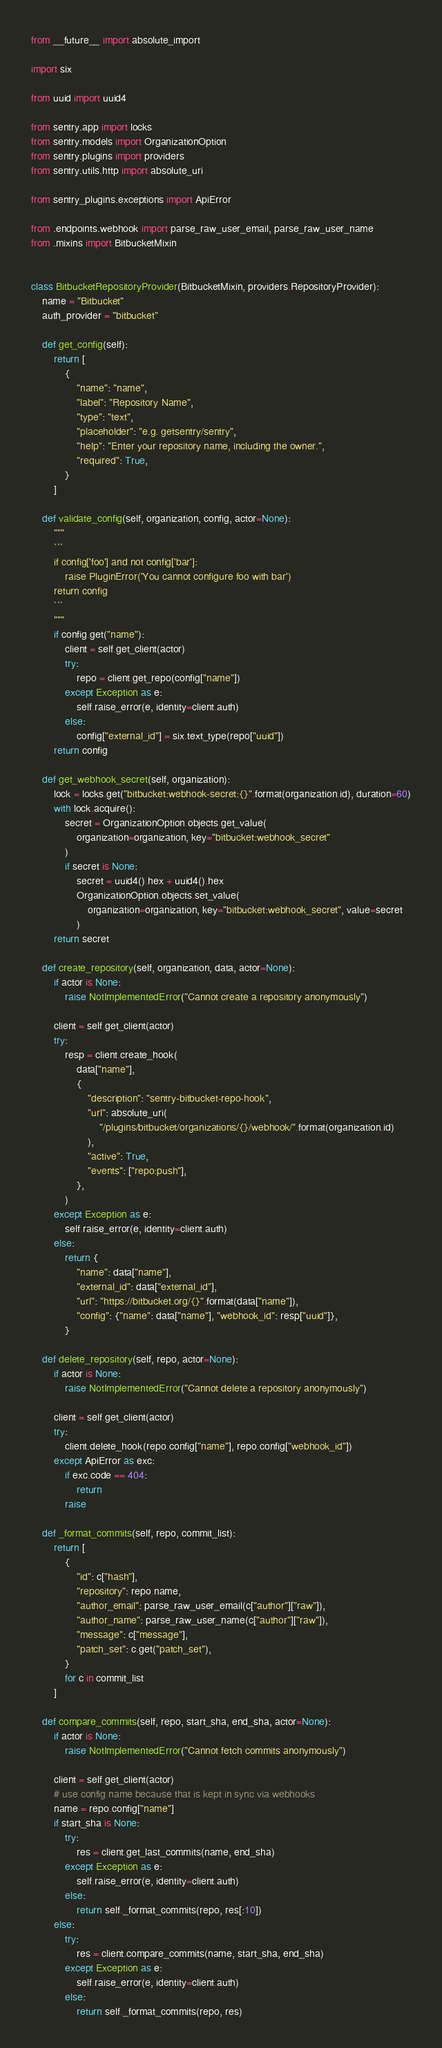<code> <loc_0><loc_0><loc_500><loc_500><_Python_>from __future__ import absolute_import

import six

from uuid import uuid4

from sentry.app import locks
from sentry.models import OrganizationOption
from sentry.plugins import providers
from sentry.utils.http import absolute_uri

from sentry_plugins.exceptions import ApiError

from .endpoints.webhook import parse_raw_user_email, parse_raw_user_name
from .mixins import BitbucketMixin


class BitbucketRepositoryProvider(BitbucketMixin, providers.RepositoryProvider):
    name = "Bitbucket"
    auth_provider = "bitbucket"

    def get_config(self):
        return [
            {
                "name": "name",
                "label": "Repository Name",
                "type": "text",
                "placeholder": "e.g. getsentry/sentry",
                "help": "Enter your repository name, including the owner.",
                "required": True,
            }
        ]

    def validate_config(self, organization, config, actor=None):
        """
        ```
        if config['foo'] and not config['bar']:
            raise PluginError('You cannot configure foo with bar')
        return config
        ```
        """
        if config.get("name"):
            client = self.get_client(actor)
            try:
                repo = client.get_repo(config["name"])
            except Exception as e:
                self.raise_error(e, identity=client.auth)
            else:
                config["external_id"] = six.text_type(repo["uuid"])
        return config

    def get_webhook_secret(self, organization):
        lock = locks.get("bitbucket:webhook-secret:{}".format(organization.id), duration=60)
        with lock.acquire():
            secret = OrganizationOption.objects.get_value(
                organization=organization, key="bitbucket:webhook_secret"
            )
            if secret is None:
                secret = uuid4().hex + uuid4().hex
                OrganizationOption.objects.set_value(
                    organization=organization, key="bitbucket:webhook_secret", value=secret
                )
        return secret

    def create_repository(self, organization, data, actor=None):
        if actor is None:
            raise NotImplementedError("Cannot create a repository anonymously")

        client = self.get_client(actor)
        try:
            resp = client.create_hook(
                data["name"],
                {
                    "description": "sentry-bitbucket-repo-hook",
                    "url": absolute_uri(
                        "/plugins/bitbucket/organizations/{}/webhook/".format(organization.id)
                    ),
                    "active": True,
                    "events": ["repo:push"],
                },
            )
        except Exception as e:
            self.raise_error(e, identity=client.auth)
        else:
            return {
                "name": data["name"],
                "external_id": data["external_id"],
                "url": "https://bitbucket.org/{}".format(data["name"]),
                "config": {"name": data["name"], "webhook_id": resp["uuid"]},
            }

    def delete_repository(self, repo, actor=None):
        if actor is None:
            raise NotImplementedError("Cannot delete a repository anonymously")

        client = self.get_client(actor)
        try:
            client.delete_hook(repo.config["name"], repo.config["webhook_id"])
        except ApiError as exc:
            if exc.code == 404:
                return
            raise

    def _format_commits(self, repo, commit_list):
        return [
            {
                "id": c["hash"],
                "repository": repo.name,
                "author_email": parse_raw_user_email(c["author"]["raw"]),
                "author_name": parse_raw_user_name(c["author"]["raw"]),
                "message": c["message"],
                "patch_set": c.get("patch_set"),
            }
            for c in commit_list
        ]

    def compare_commits(self, repo, start_sha, end_sha, actor=None):
        if actor is None:
            raise NotImplementedError("Cannot fetch commits anonymously")

        client = self.get_client(actor)
        # use config name because that is kept in sync via webhooks
        name = repo.config["name"]
        if start_sha is None:
            try:
                res = client.get_last_commits(name, end_sha)
            except Exception as e:
                self.raise_error(e, identity=client.auth)
            else:
                return self._format_commits(repo, res[:10])
        else:
            try:
                res = client.compare_commits(name, start_sha, end_sha)
            except Exception as e:
                self.raise_error(e, identity=client.auth)
            else:
                return self._format_commits(repo, res)
</code> 